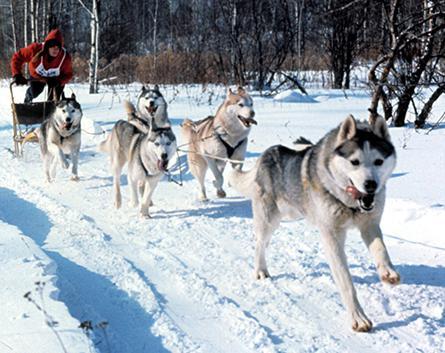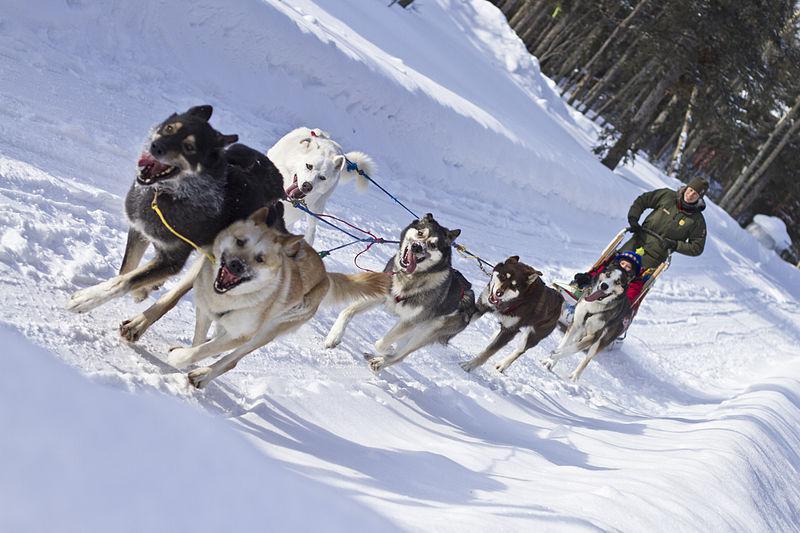The first image is the image on the left, the second image is the image on the right. Evaluate the accuracy of this statement regarding the images: "Right image shows a sled team heading rightward and downward, with no vegetation along the trail.". Is it true? Answer yes or no. No. The first image is the image on the left, the second image is the image on the right. Assess this claim about the two images: "The lead dog pulling the team is tan.". Correct or not? Answer yes or no. No. 